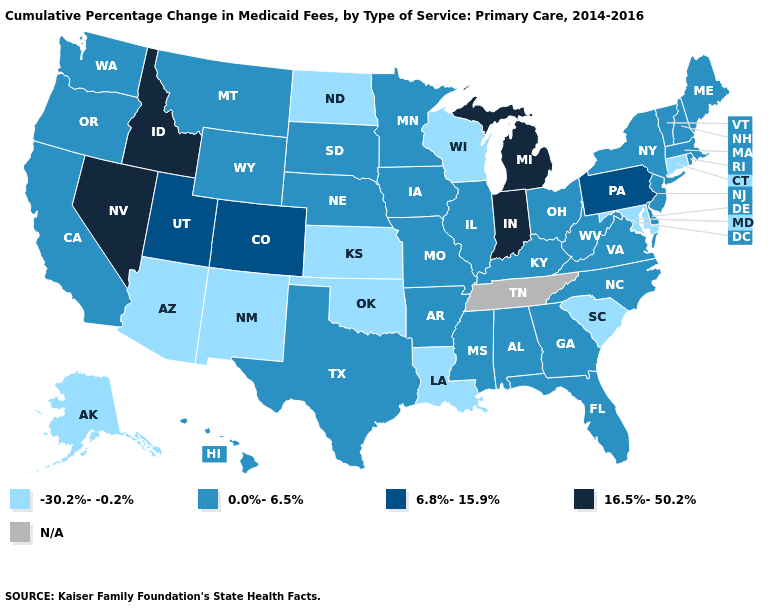What is the highest value in states that border South Dakota?
Give a very brief answer. 0.0%-6.5%. What is the value of Wisconsin?
Concise answer only. -30.2%--0.2%. Which states have the lowest value in the USA?
Quick response, please. Alaska, Arizona, Connecticut, Kansas, Louisiana, Maryland, New Mexico, North Dakota, Oklahoma, South Carolina, Wisconsin. Name the states that have a value in the range 0.0%-6.5%?
Write a very short answer. Alabama, Arkansas, California, Delaware, Florida, Georgia, Hawaii, Illinois, Iowa, Kentucky, Maine, Massachusetts, Minnesota, Mississippi, Missouri, Montana, Nebraska, New Hampshire, New Jersey, New York, North Carolina, Ohio, Oregon, Rhode Island, South Dakota, Texas, Vermont, Virginia, Washington, West Virginia, Wyoming. What is the lowest value in states that border Connecticut?
Answer briefly. 0.0%-6.5%. What is the value of Connecticut?
Quick response, please. -30.2%--0.2%. Name the states that have a value in the range 16.5%-50.2%?
Short answer required. Idaho, Indiana, Michigan, Nevada. What is the value of Iowa?
Write a very short answer. 0.0%-6.5%. Does the first symbol in the legend represent the smallest category?
Quick response, please. Yes. What is the highest value in states that border Oklahoma?
Quick response, please. 6.8%-15.9%. Does Arizona have the highest value in the USA?
Short answer required. No. Name the states that have a value in the range -30.2%--0.2%?
Short answer required. Alaska, Arizona, Connecticut, Kansas, Louisiana, Maryland, New Mexico, North Dakota, Oklahoma, South Carolina, Wisconsin. What is the value of Nebraska?
Concise answer only. 0.0%-6.5%. Which states have the highest value in the USA?
Answer briefly. Idaho, Indiana, Michigan, Nevada. What is the highest value in the Northeast ?
Give a very brief answer. 6.8%-15.9%. 